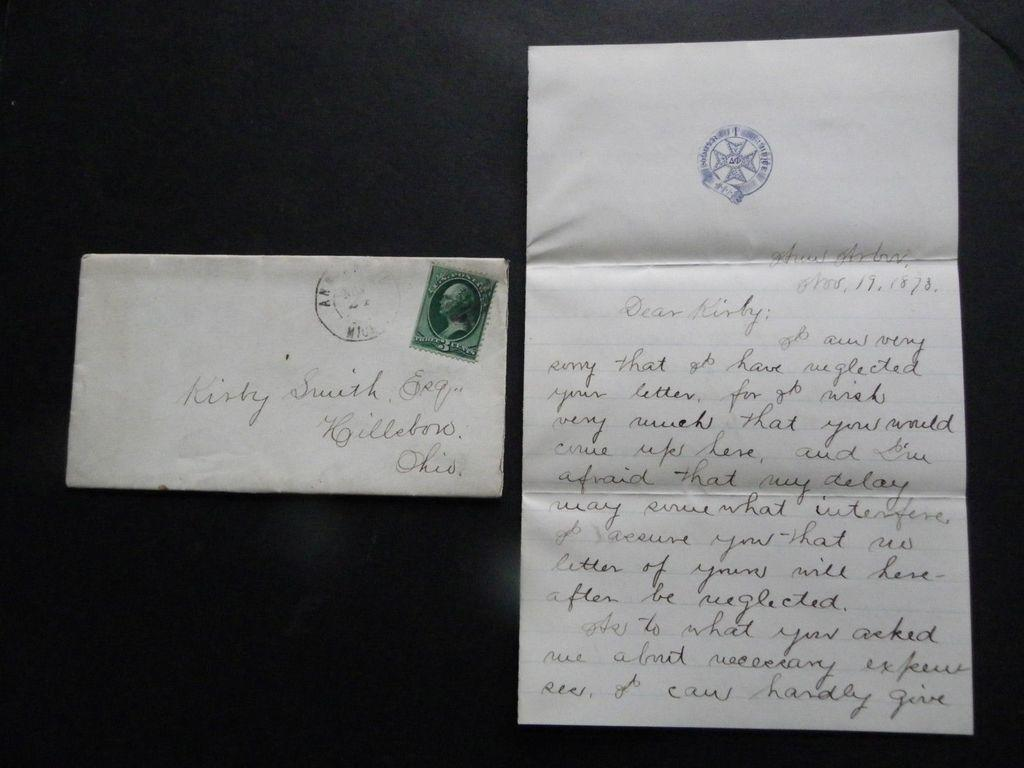<image>
Render a clear and concise summary of the photo. Fancy script graces the envelope and a letter written to Kirby Smith. 